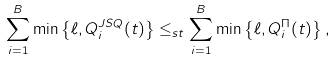<formula> <loc_0><loc_0><loc_500><loc_500>\sum _ { i = 1 } ^ { B } \min \left \{ \ell , Q _ { i } ^ { J S Q } ( t ) \right \} \leq _ { s t } \sum _ { i = 1 } ^ { B } \min \left \{ \ell , Q _ { i } ^ { \Pi } ( t ) \right \} ,</formula> 